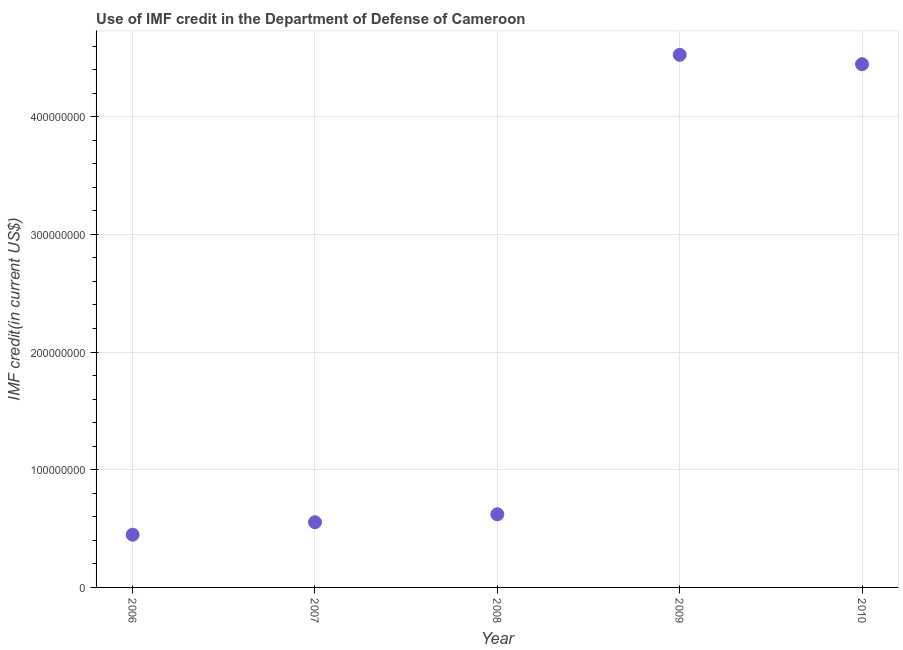What is the use of imf credit in dod in 2010?
Your answer should be very brief. 4.45e+08. Across all years, what is the maximum use of imf credit in dod?
Give a very brief answer. 4.53e+08. Across all years, what is the minimum use of imf credit in dod?
Offer a very short reply. 4.48e+07. In which year was the use of imf credit in dod maximum?
Give a very brief answer. 2009. What is the sum of the use of imf credit in dod?
Give a very brief answer. 1.06e+09. What is the difference between the use of imf credit in dod in 2006 and 2010?
Give a very brief answer. -4.00e+08. What is the average use of imf credit in dod per year?
Offer a terse response. 2.12e+08. What is the median use of imf credit in dod?
Give a very brief answer. 6.22e+07. In how many years, is the use of imf credit in dod greater than 420000000 US$?
Give a very brief answer. 2. What is the ratio of the use of imf credit in dod in 2009 to that in 2010?
Give a very brief answer. 1.02. Is the use of imf credit in dod in 2007 less than that in 2009?
Make the answer very short. Yes. What is the difference between the highest and the second highest use of imf credit in dod?
Provide a short and direct response. 7.98e+06. Is the sum of the use of imf credit in dod in 2009 and 2010 greater than the maximum use of imf credit in dod across all years?
Your answer should be compact. Yes. What is the difference between the highest and the lowest use of imf credit in dod?
Make the answer very short. 4.08e+08. Does the use of imf credit in dod monotonically increase over the years?
Your answer should be very brief. No. Are the values on the major ticks of Y-axis written in scientific E-notation?
Your response must be concise. No. Does the graph contain any zero values?
Your answer should be very brief. No. What is the title of the graph?
Give a very brief answer. Use of IMF credit in the Department of Defense of Cameroon. What is the label or title of the X-axis?
Your answer should be very brief. Year. What is the label or title of the Y-axis?
Your response must be concise. IMF credit(in current US$). What is the IMF credit(in current US$) in 2006?
Provide a succinct answer. 4.48e+07. What is the IMF credit(in current US$) in 2007?
Ensure brevity in your answer.  5.54e+07. What is the IMF credit(in current US$) in 2008?
Keep it short and to the point. 6.22e+07. What is the IMF credit(in current US$) in 2009?
Ensure brevity in your answer.  4.53e+08. What is the IMF credit(in current US$) in 2010?
Offer a terse response. 4.45e+08. What is the difference between the IMF credit(in current US$) in 2006 and 2007?
Offer a terse response. -1.06e+07. What is the difference between the IMF credit(in current US$) in 2006 and 2008?
Your answer should be compact. -1.74e+07. What is the difference between the IMF credit(in current US$) in 2006 and 2009?
Provide a succinct answer. -4.08e+08. What is the difference between the IMF credit(in current US$) in 2006 and 2010?
Make the answer very short. -4.00e+08. What is the difference between the IMF credit(in current US$) in 2007 and 2008?
Make the answer very short. -6.76e+06. What is the difference between the IMF credit(in current US$) in 2007 and 2009?
Make the answer very short. -3.97e+08. What is the difference between the IMF credit(in current US$) in 2007 and 2010?
Your response must be concise. -3.89e+08. What is the difference between the IMF credit(in current US$) in 2008 and 2009?
Keep it short and to the point. -3.90e+08. What is the difference between the IMF credit(in current US$) in 2008 and 2010?
Make the answer very short. -3.82e+08. What is the difference between the IMF credit(in current US$) in 2009 and 2010?
Give a very brief answer. 7.98e+06. What is the ratio of the IMF credit(in current US$) in 2006 to that in 2007?
Make the answer very short. 0.81. What is the ratio of the IMF credit(in current US$) in 2006 to that in 2008?
Ensure brevity in your answer.  0.72. What is the ratio of the IMF credit(in current US$) in 2006 to that in 2009?
Provide a short and direct response. 0.1. What is the ratio of the IMF credit(in current US$) in 2006 to that in 2010?
Provide a succinct answer. 0.1. What is the ratio of the IMF credit(in current US$) in 2007 to that in 2008?
Give a very brief answer. 0.89. What is the ratio of the IMF credit(in current US$) in 2007 to that in 2009?
Offer a very short reply. 0.12. What is the ratio of the IMF credit(in current US$) in 2007 to that in 2010?
Make the answer very short. 0.12. What is the ratio of the IMF credit(in current US$) in 2008 to that in 2009?
Provide a short and direct response. 0.14. What is the ratio of the IMF credit(in current US$) in 2008 to that in 2010?
Provide a short and direct response. 0.14. 